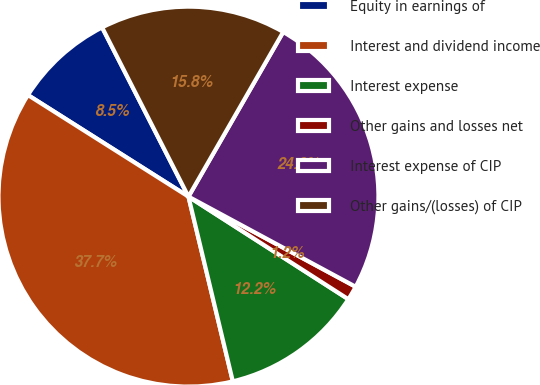Convert chart to OTSL. <chart><loc_0><loc_0><loc_500><loc_500><pie_chart><fcel>Equity in earnings of<fcel>Interest and dividend income<fcel>Interest expense<fcel>Other gains and losses net<fcel>Interest expense of CIP<fcel>Other gains/(losses) of CIP<nl><fcel>8.51%<fcel>37.73%<fcel>12.17%<fcel>1.21%<fcel>24.56%<fcel>15.82%<nl></chart> 